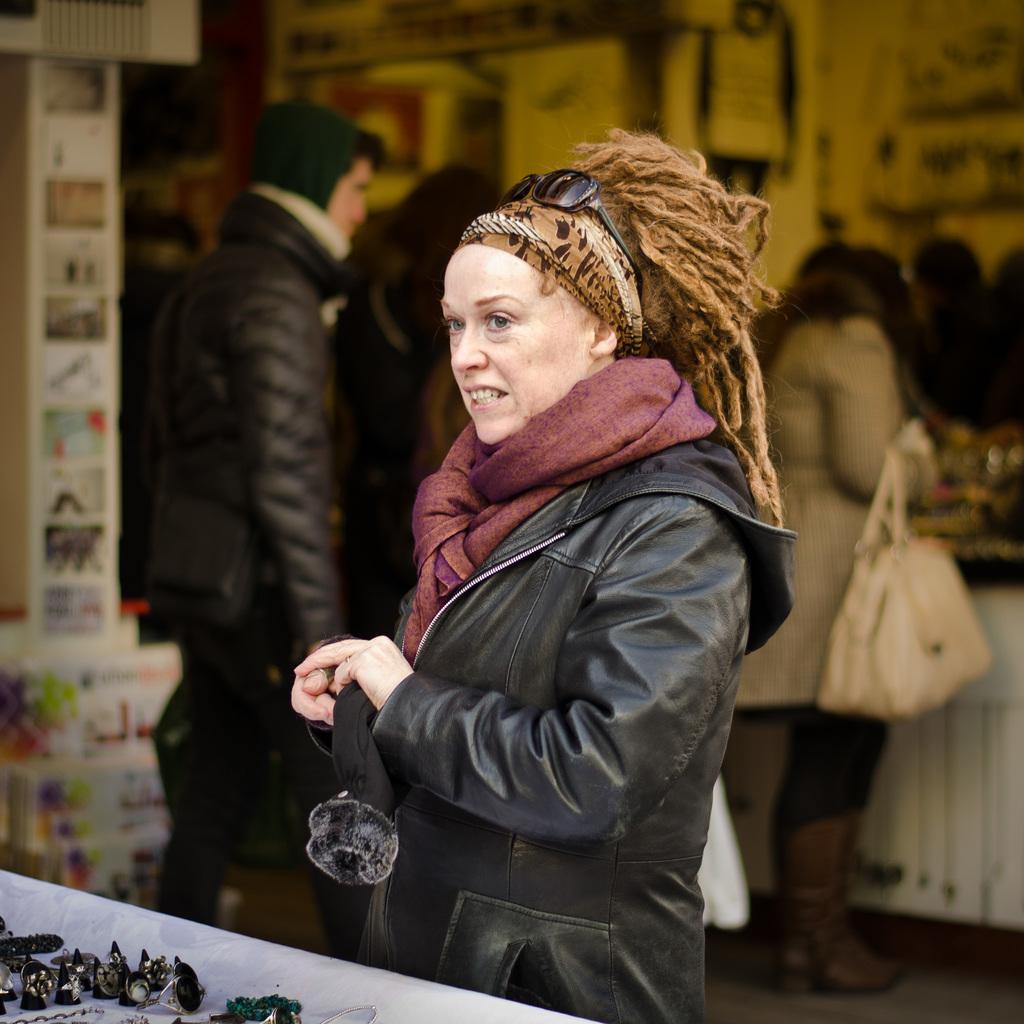How would you summarize this image in a sentence or two? In this image there is a person standing and holding an object , and there are some items on the table , and in the background there are papers stick to the wall and there are group of people standing. 